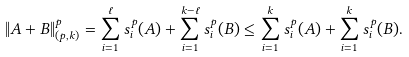<formula> <loc_0><loc_0><loc_500><loc_500>\| A + B \| _ { ( p , k ) } ^ { p } = \sum _ { i = 1 } ^ { \ell } s _ { i } ^ { p } ( A ) + \sum _ { i = 1 } ^ { k - \ell } s _ { i } ^ { p } ( B ) \leq \sum _ { i = 1 } ^ { k } s _ { i } ^ { p } ( A ) + \sum _ { i = 1 } ^ { k } s _ { i } ^ { p } ( B ) .</formula> 